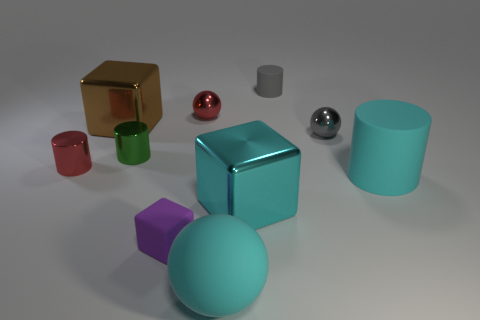Are there any objects that share the same shape but differ in size? Yes, there are two cylindrical objects that share the same shape but differ in size. The larger one is cyan, located to the right side of the image, while the smaller one is gray and situated to the left of the cyan cylinder.  Can you tell if the lighting in the scene is natural or artificial? The lighting in the scene appears to be artificial as it is evenly distributed, with soft shadows indicating a controlled environment typically found in a studio setup. 